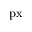Convert formula to latex. <formula><loc_0><loc_0><loc_500><loc_500>p x</formula> 